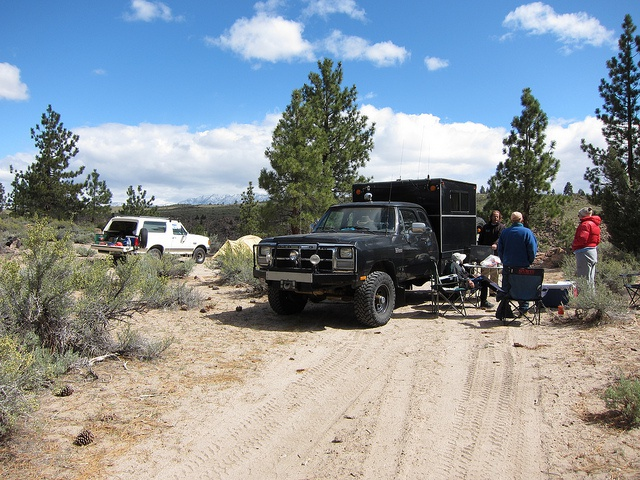Describe the objects in this image and their specific colors. I can see truck in gray, black, darkgray, and purple tones, truck in gray, whitesmoke, black, and darkgray tones, car in gray, whitesmoke, black, and darkgray tones, chair in gray, black, maroon, and tan tones, and people in gray, black, navy, and blue tones in this image. 